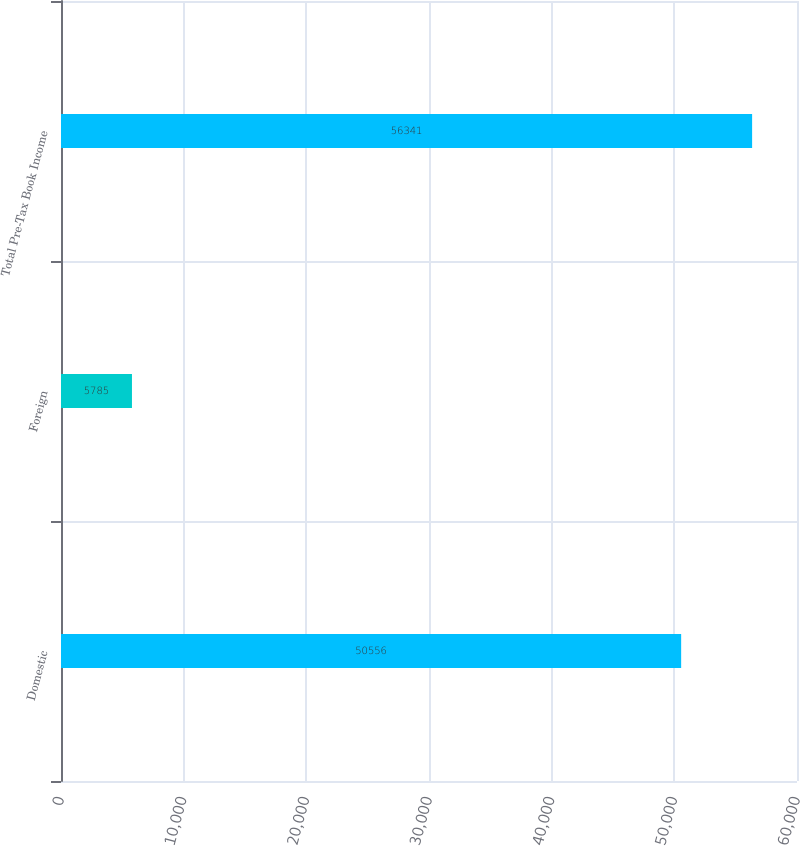<chart> <loc_0><loc_0><loc_500><loc_500><bar_chart><fcel>Domestic<fcel>Foreign<fcel>Total Pre-Tax Book Income<nl><fcel>50556<fcel>5785<fcel>56341<nl></chart> 